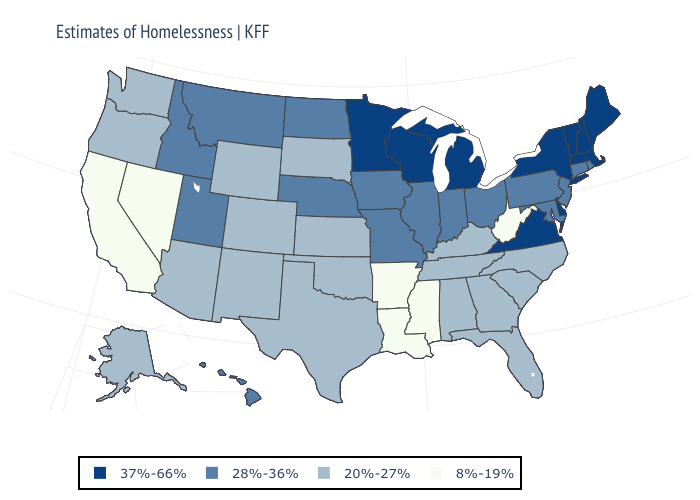Does West Virginia have the lowest value in the USA?
Concise answer only. Yes. Name the states that have a value in the range 37%-66%?
Short answer required. Delaware, Maine, Massachusetts, Michigan, Minnesota, New Hampshire, New York, Vermont, Virginia, Wisconsin. Name the states that have a value in the range 37%-66%?
Answer briefly. Delaware, Maine, Massachusetts, Michigan, Minnesota, New Hampshire, New York, Vermont, Virginia, Wisconsin. What is the lowest value in states that border Louisiana?
Answer briefly. 8%-19%. Which states have the highest value in the USA?
Give a very brief answer. Delaware, Maine, Massachusetts, Michigan, Minnesota, New Hampshire, New York, Vermont, Virginia, Wisconsin. What is the value of Illinois?
Answer briefly. 28%-36%. What is the value of Louisiana?
Keep it brief. 8%-19%. Name the states that have a value in the range 20%-27%?
Answer briefly. Alabama, Alaska, Arizona, Colorado, Florida, Georgia, Kansas, Kentucky, New Mexico, North Carolina, Oklahoma, Oregon, South Carolina, South Dakota, Tennessee, Texas, Washington, Wyoming. What is the value of Alabama?
Concise answer only. 20%-27%. What is the lowest value in states that border Wyoming?
Keep it brief. 20%-27%. Name the states that have a value in the range 28%-36%?
Answer briefly. Connecticut, Hawaii, Idaho, Illinois, Indiana, Iowa, Maryland, Missouri, Montana, Nebraska, New Jersey, North Dakota, Ohio, Pennsylvania, Rhode Island, Utah. Which states hav the highest value in the Northeast?
Be succinct. Maine, Massachusetts, New Hampshire, New York, Vermont. Does Ohio have a higher value than Hawaii?
Give a very brief answer. No. Which states hav the highest value in the South?
Answer briefly. Delaware, Virginia. What is the value of North Carolina?
Keep it brief. 20%-27%. 